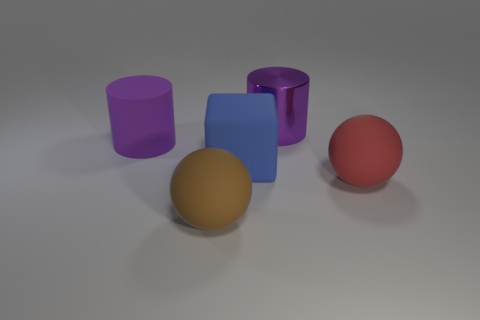Add 1 large cyan rubber balls. How many objects exist? 6 Subtract all cylinders. How many objects are left? 3 Subtract 0 gray cubes. How many objects are left? 5 Subtract all small green matte things. Subtract all big red objects. How many objects are left? 4 Add 1 blue objects. How many blue objects are left? 2 Add 3 rubber cylinders. How many rubber cylinders exist? 4 